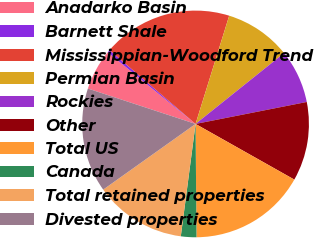Convert chart. <chart><loc_0><loc_0><loc_500><loc_500><pie_chart><fcel>Anadarko Basin<fcel>Barnett Shale<fcel>Mississippian-Woodford Trend<fcel>Permian Basin<fcel>Rockies<fcel>Other<fcel>Total US<fcel>Canada<fcel>Total retained properties<fcel>Divested properties<nl><fcel>5.83%<fcel>0.4%<fcel>18.51%<fcel>9.46%<fcel>7.64%<fcel>11.27%<fcel>16.7%<fcel>2.21%<fcel>13.08%<fcel>14.89%<nl></chart> 